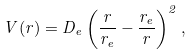Convert formula to latex. <formula><loc_0><loc_0><loc_500><loc_500>V ( r ) = D _ { e } \left ( \frac { r } { r _ { e } } - \frac { r _ { e } } { r } \right ) ^ { 2 } ,</formula> 